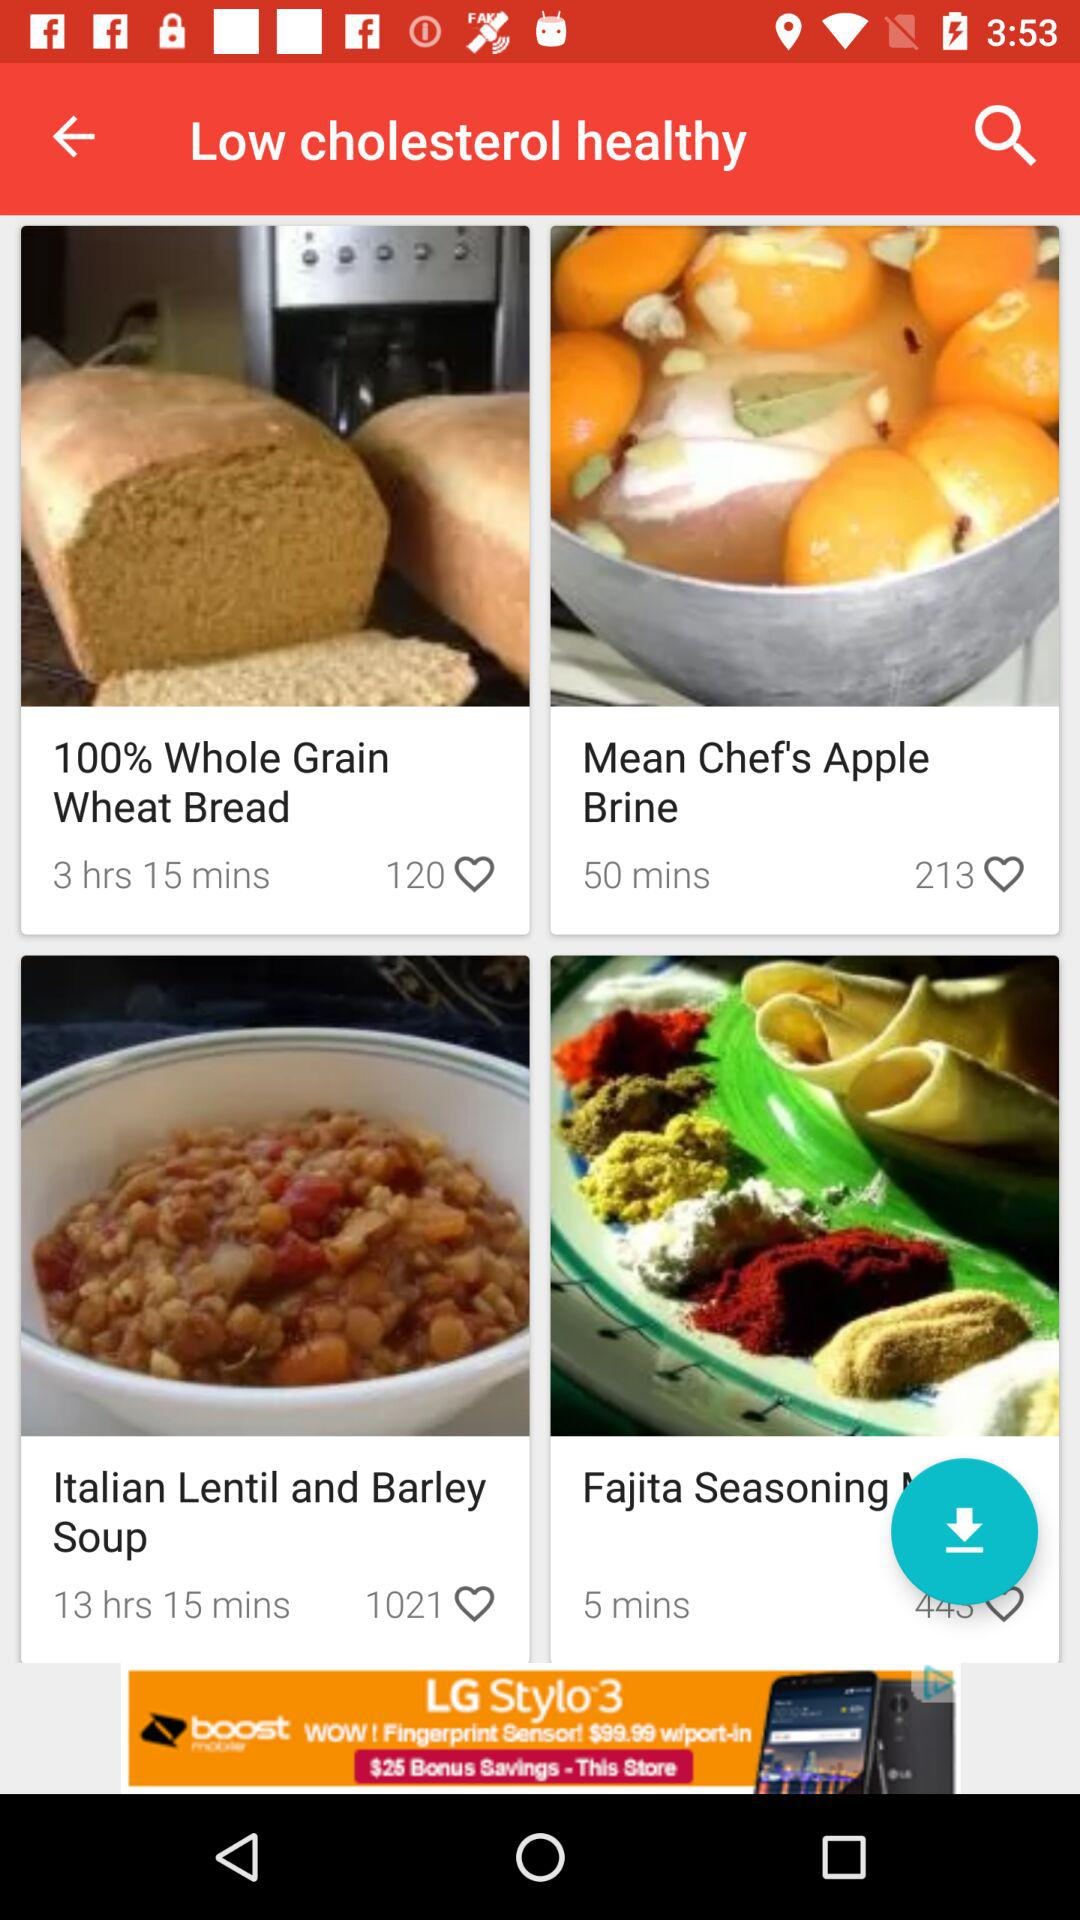What is the duration of the mean chef's apple brine? The duration is 50 minutes. 